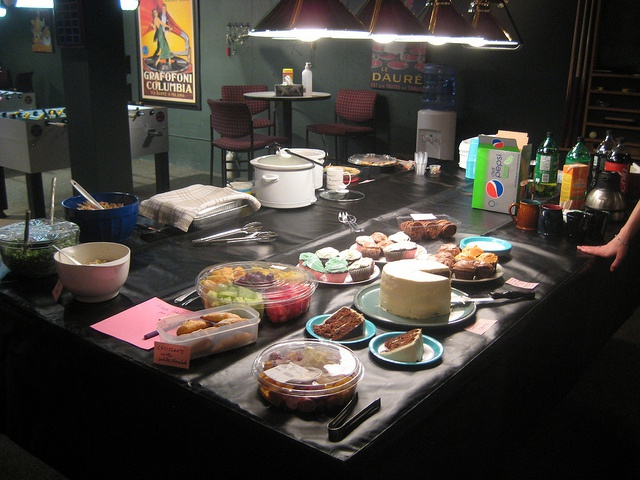Describe the objects in this image and their specific colors. I can see dining table in gray, black, and darkgray tones, dining table in gray, black, maroon, and darkgray tones, cake in gray, white, and olive tones, bowl in gray, black, maroon, and brown tones, and bowl in gray, black, and darkgray tones in this image. 